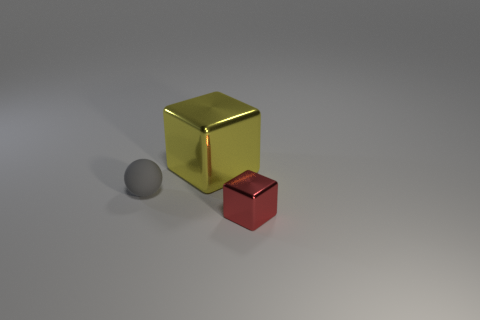Imagine these objects were part of a larger set, what could that set be used for? If these objects were part of a larger set, they might be used as teaching tools in a classroom setting to explain concepts such as geometry, volume, and physics. They could also be part of a decorative arrangement or be pieces in an abstract art installation, relying on their elemental shapes and colors to contribute to the aesthetic of the setting. In a gaming context, they could be game pieces for a strategy board game, each representing different values or powers. 